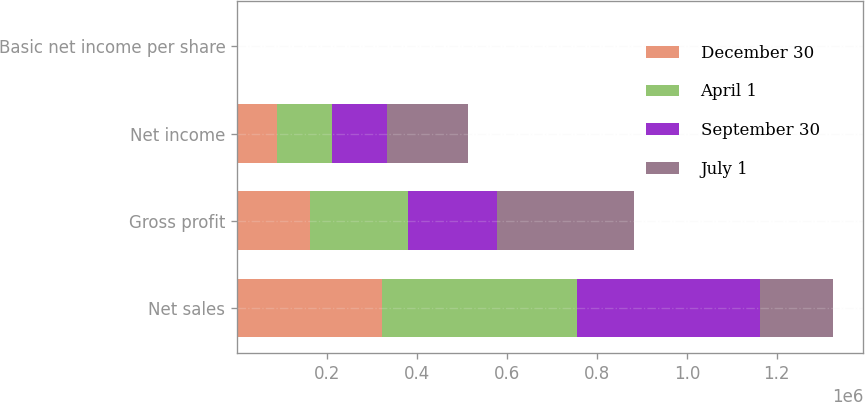<chart> <loc_0><loc_0><loc_500><loc_500><stacked_bar_chart><ecel><fcel>Net sales<fcel>Gross profit<fcel>Net income<fcel>Basic net income per share<nl><fcel>December 30<fcel>322311<fcel>162790<fcel>87516<fcel>0.4<nl><fcel>April 1<fcel>432468<fcel>216284<fcel>123286<fcel>0.57<nl><fcel>September 30<fcel>407997<fcel>198860<fcel>122978<fcel>0.57<nl><fcel>July 1<fcel>162790<fcel>304452<fcel>180343<fcel>0.84<nl></chart> 